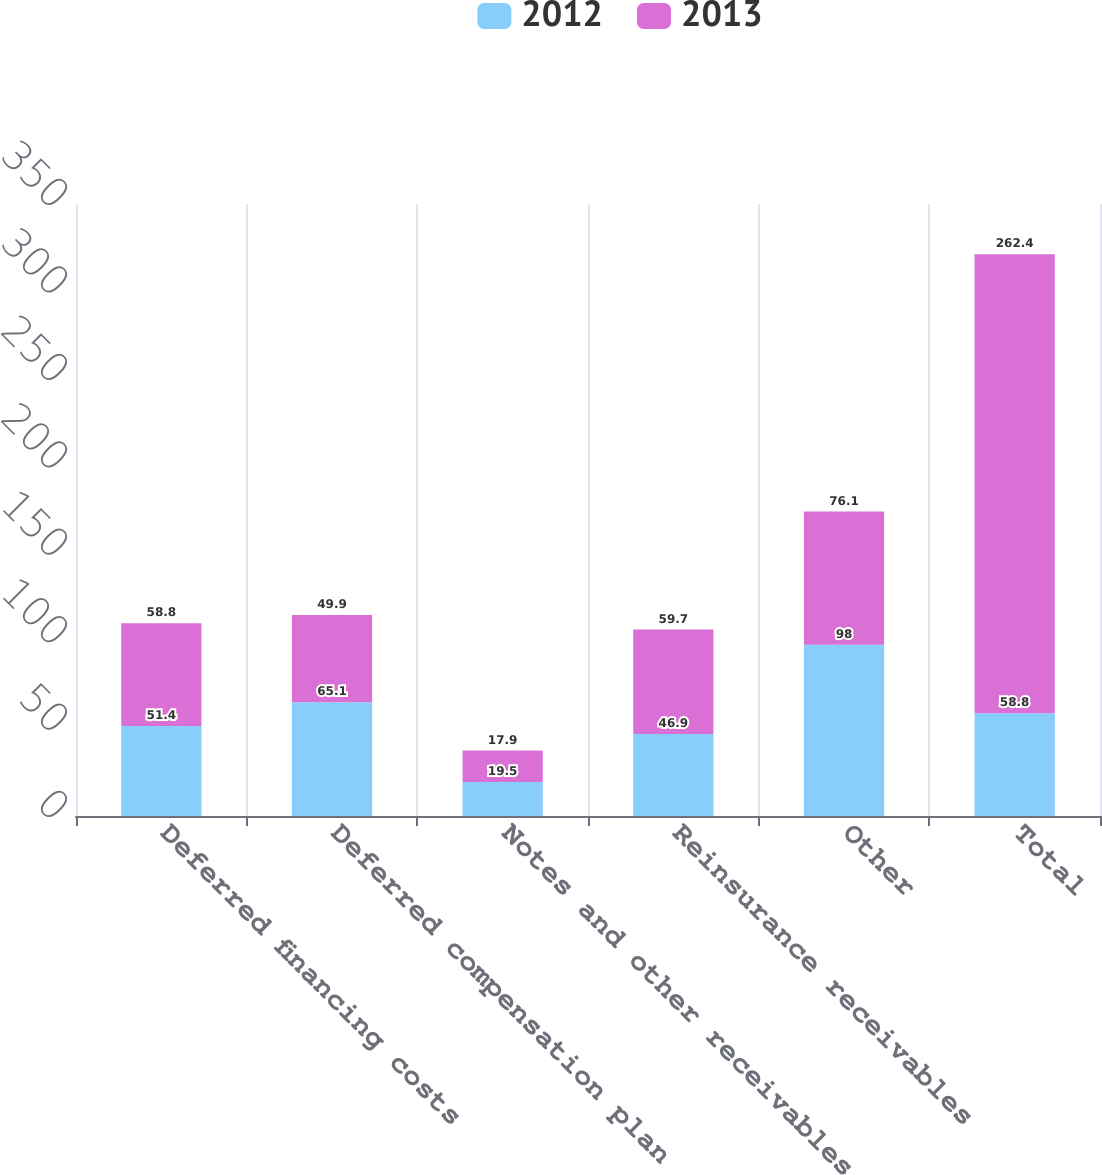Convert chart to OTSL. <chart><loc_0><loc_0><loc_500><loc_500><stacked_bar_chart><ecel><fcel>Deferred financing costs<fcel>Deferred compensation plan<fcel>Notes and other receivables<fcel>Reinsurance receivables<fcel>Other<fcel>Total<nl><fcel>2012<fcel>51.4<fcel>65.1<fcel>19.5<fcel>46.9<fcel>98<fcel>58.8<nl><fcel>2013<fcel>58.8<fcel>49.9<fcel>17.9<fcel>59.7<fcel>76.1<fcel>262.4<nl></chart> 